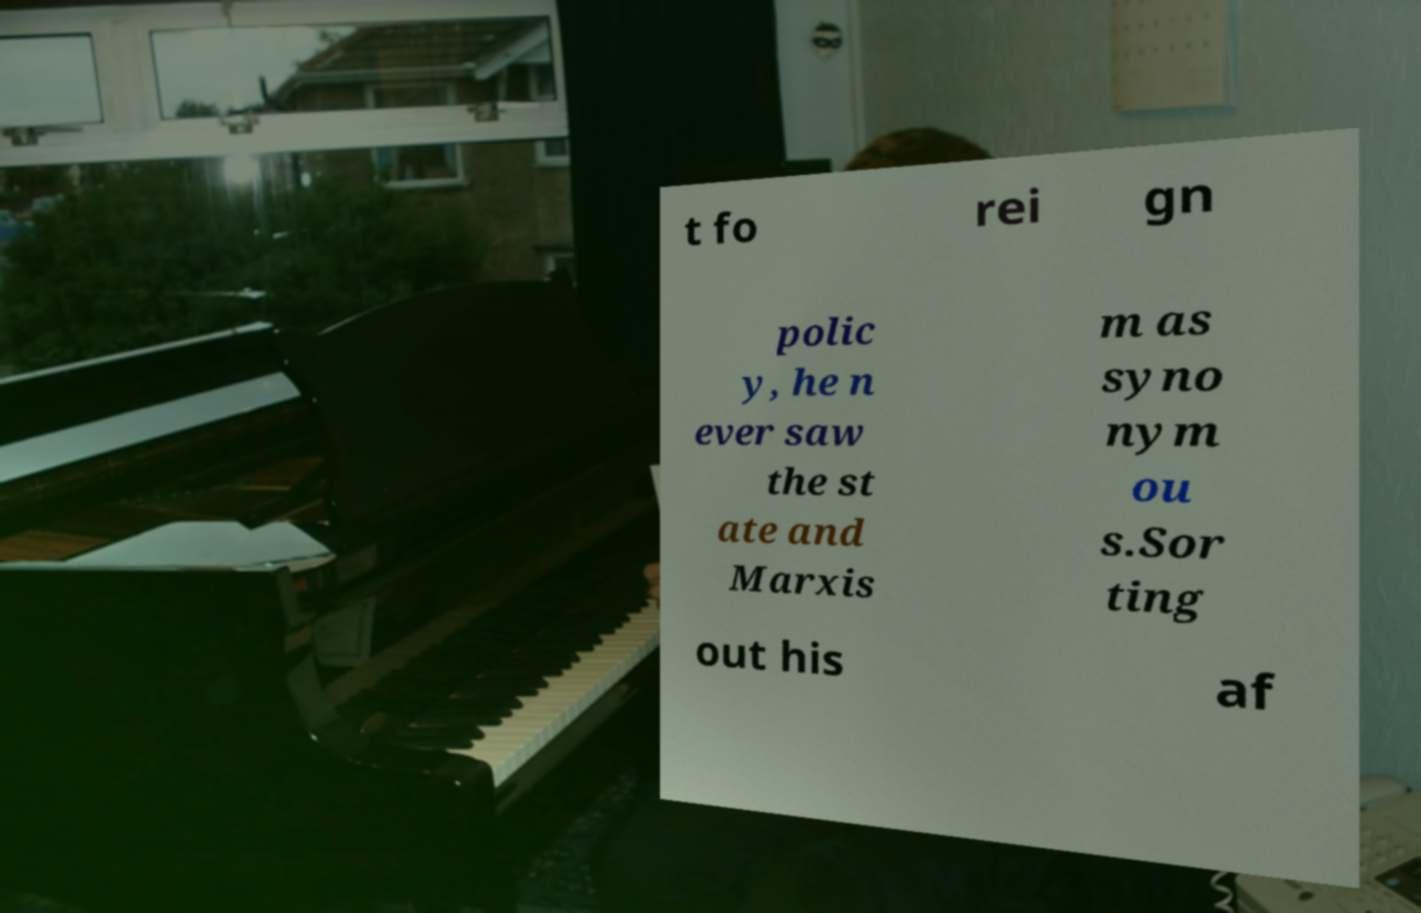Could you assist in decoding the text presented in this image and type it out clearly? t fo rei gn polic y, he n ever saw the st ate and Marxis m as syno nym ou s.Sor ting out his af 